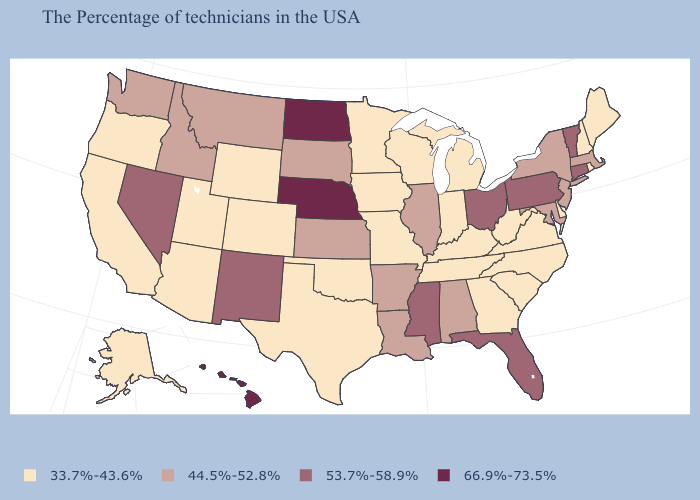Among the states that border New Hampshire , does Maine have the highest value?
Be succinct. No. Does Vermont have the lowest value in the Northeast?
Short answer required. No. What is the value of Ohio?
Quick response, please. 53.7%-58.9%. Which states have the highest value in the USA?
Concise answer only. Nebraska, North Dakota, Hawaii. Name the states that have a value in the range 33.7%-43.6%?
Give a very brief answer. Maine, Rhode Island, New Hampshire, Delaware, Virginia, North Carolina, South Carolina, West Virginia, Georgia, Michigan, Kentucky, Indiana, Tennessee, Wisconsin, Missouri, Minnesota, Iowa, Oklahoma, Texas, Wyoming, Colorado, Utah, Arizona, California, Oregon, Alaska. What is the lowest value in the West?
Short answer required. 33.7%-43.6%. What is the value of Nebraska?
Keep it brief. 66.9%-73.5%. Is the legend a continuous bar?
Be succinct. No. Name the states that have a value in the range 33.7%-43.6%?
Concise answer only. Maine, Rhode Island, New Hampshire, Delaware, Virginia, North Carolina, South Carolina, West Virginia, Georgia, Michigan, Kentucky, Indiana, Tennessee, Wisconsin, Missouri, Minnesota, Iowa, Oklahoma, Texas, Wyoming, Colorado, Utah, Arizona, California, Oregon, Alaska. What is the lowest value in states that border Massachusetts?
Keep it brief. 33.7%-43.6%. Name the states that have a value in the range 53.7%-58.9%?
Short answer required. Vermont, Connecticut, Pennsylvania, Ohio, Florida, Mississippi, New Mexico, Nevada. Name the states that have a value in the range 66.9%-73.5%?
Answer briefly. Nebraska, North Dakota, Hawaii. Among the states that border Ohio , which have the lowest value?
Keep it brief. West Virginia, Michigan, Kentucky, Indiana. Name the states that have a value in the range 44.5%-52.8%?
Concise answer only. Massachusetts, New York, New Jersey, Maryland, Alabama, Illinois, Louisiana, Arkansas, Kansas, South Dakota, Montana, Idaho, Washington. What is the value of Montana?
Answer briefly. 44.5%-52.8%. 